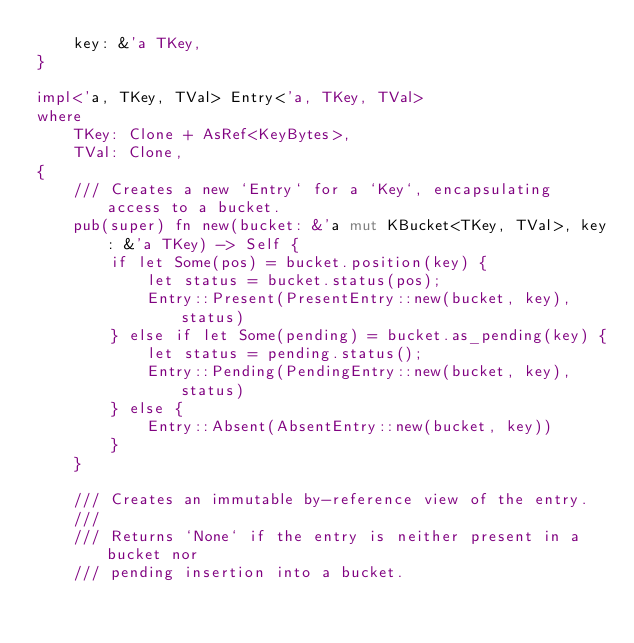Convert code to text. <code><loc_0><loc_0><loc_500><loc_500><_Rust_>    key: &'a TKey,
}

impl<'a, TKey, TVal> Entry<'a, TKey, TVal>
where
    TKey: Clone + AsRef<KeyBytes>,
    TVal: Clone,
{
    /// Creates a new `Entry` for a `Key`, encapsulating access to a bucket.
    pub(super) fn new(bucket: &'a mut KBucket<TKey, TVal>, key: &'a TKey) -> Self {
        if let Some(pos) = bucket.position(key) {
            let status = bucket.status(pos);
            Entry::Present(PresentEntry::new(bucket, key), status)
        } else if let Some(pending) = bucket.as_pending(key) {
            let status = pending.status();
            Entry::Pending(PendingEntry::new(bucket, key), status)
        } else {
            Entry::Absent(AbsentEntry::new(bucket, key))
        }
    }

    /// Creates an immutable by-reference view of the entry.
    ///
    /// Returns `None` if the entry is neither present in a bucket nor
    /// pending insertion into a bucket.</code> 